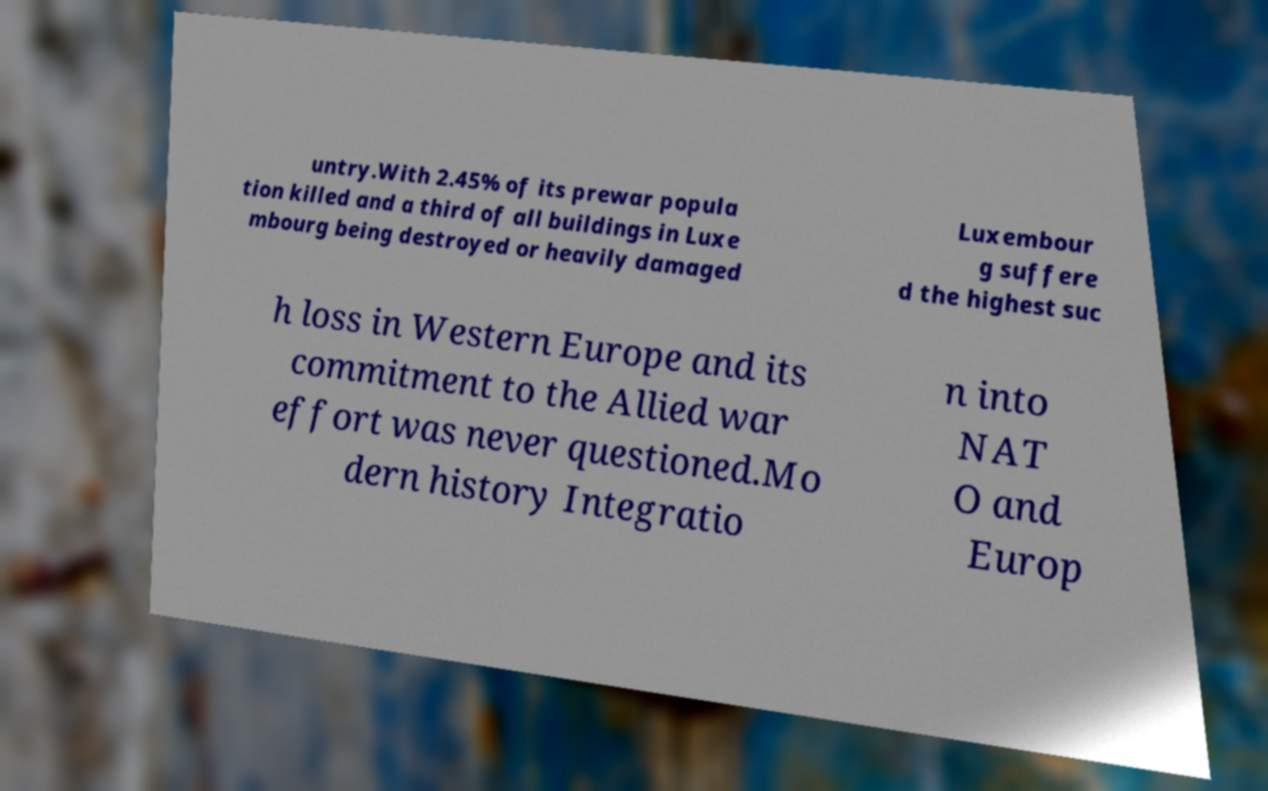Please identify and transcribe the text found in this image. untry.With 2.45% of its prewar popula tion killed and a third of all buildings in Luxe mbourg being destroyed or heavily damaged Luxembour g suffere d the highest suc h loss in Western Europe and its commitment to the Allied war effort was never questioned.Mo dern history Integratio n into NAT O and Europ 